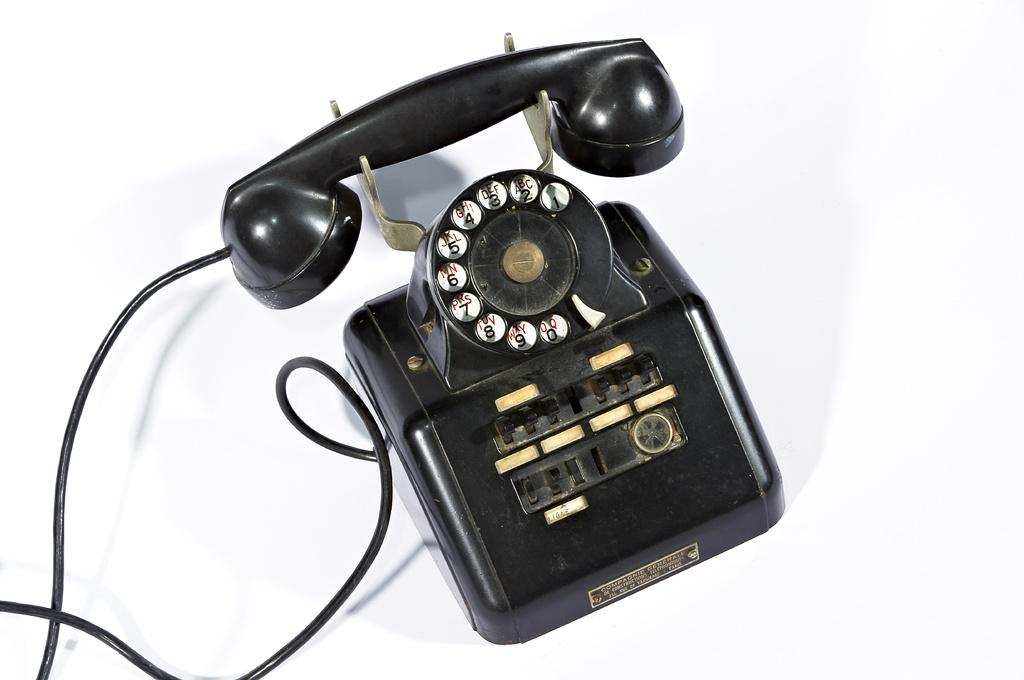<image>
Create a compact narrative representing the image presented. a phone has the number 9 on it 